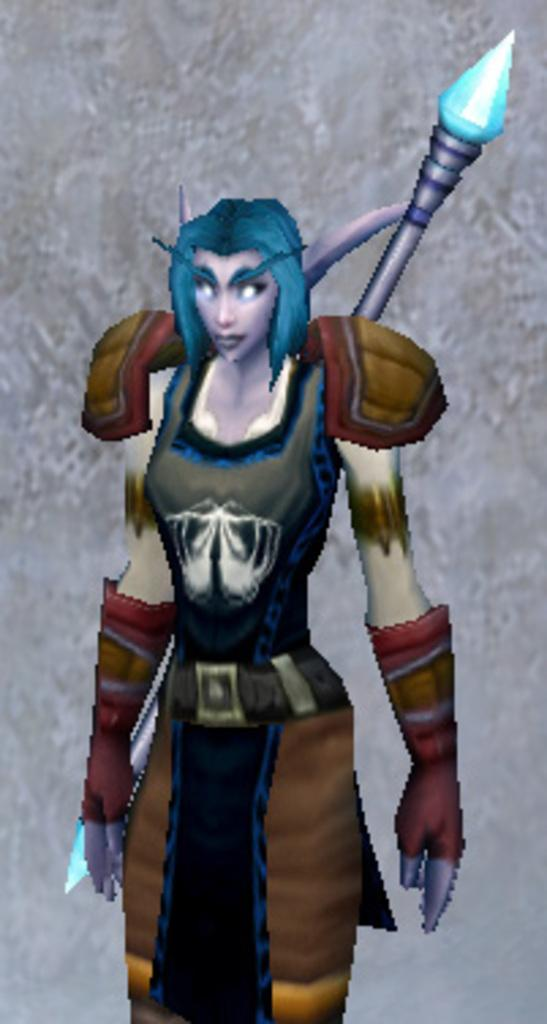What type of image is being described? The image is animated. Can you describe the main subject in the image? There is a person in the image. What can be said about the background of the image? The background of the image is blurry. What type of soup is being served in the image? There is no soup present in the image; it is an animated image with a person as the main subject and a blurry background. How many frogs are visible in the image? There are no frogs present in the image. 